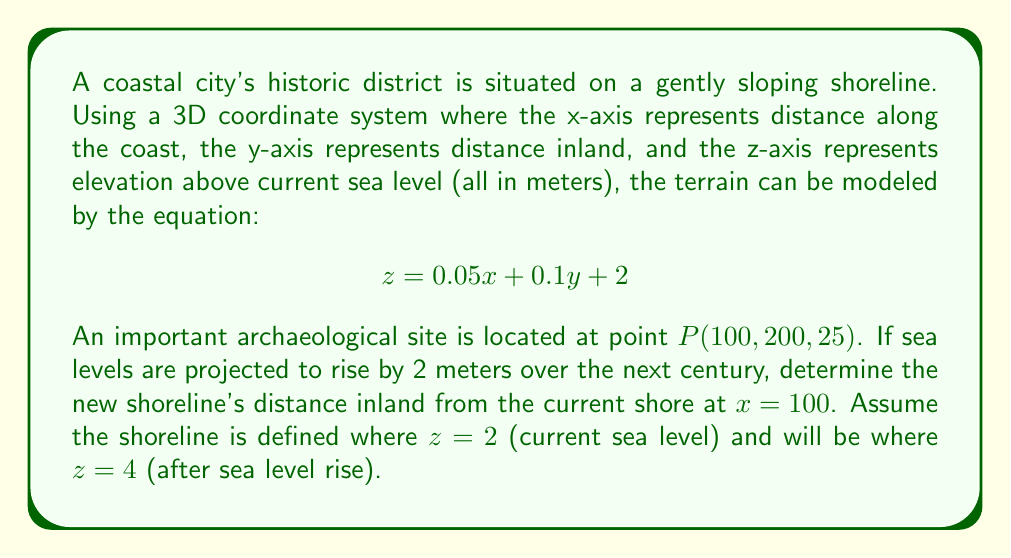What is the answer to this math problem? To solve this problem, we'll follow these steps:

1) The current shoreline is where $z = 2$. We can find this by setting $z = 2$ in the equation:

   $$2 = 0.05x + 0.1y + 2$$

2) Simplify:

   $$0 = 0.05x + 0.1y$$

3) For $x = 100$, solve for $y$:

   $$0 = 0.05(100) + 0.1y$$
   $$0 = 5 + 0.1y$$
   $$-5 = 0.1y$$
   $$y = -50$$

   This means the current shoreline is 50 meters out to sea at $x = 100$.

4) For the future shoreline where $z = 4$, we set up a similar equation:

   $$4 = 0.05x + 0.1y + 2$$

5) Simplify:

   $$2 = 0.05x + 0.1y$$

6) Again, for $x = 100$, solve for $y$:

   $$2 = 0.05(100) + 0.1y$$
   $$2 = 5 + 0.1y$$
   $$-3 = 0.1y$$
   $$y = -30$$

7) The difference between the future and current shoreline positions gives us the inland distance:

   $$-30 - (-50) = 20$$

Therefore, the new shoreline will be 20 meters inland from the current shore at $x = 100$.
Answer: The new shoreline will be 20 meters inland from the current shore at $x = 100$. 